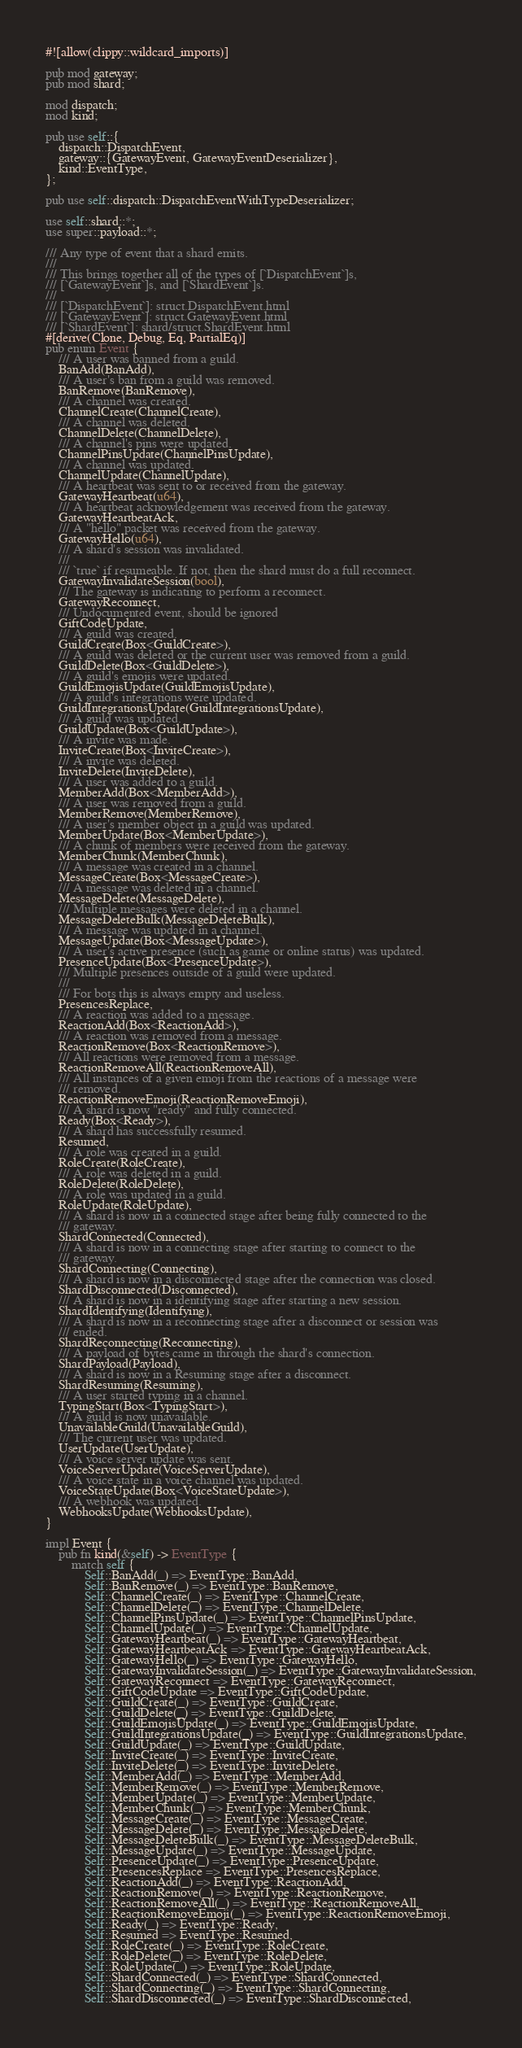<code> <loc_0><loc_0><loc_500><loc_500><_Rust_>#![allow(clippy::wildcard_imports)]

pub mod gateway;
pub mod shard;

mod dispatch;
mod kind;

pub use self::{
    dispatch::DispatchEvent,
    gateway::{GatewayEvent, GatewayEventDeserializer},
    kind::EventType,
};

pub use self::dispatch::DispatchEventWithTypeDeserializer;

use self::shard::*;
use super::payload::*;

/// Any type of event that a shard emits.
///
/// This brings together all of the types of [`DispatchEvent`]s,
/// [`GatewayEvent`]s, and [`ShardEvent`]s.
///
/// [`DispatchEvent`]: struct.DispatchEvent.html
/// [`GatewayEvent`]: struct.GatewayEvent.html
/// [`ShardEvent`]: shard/struct.ShardEvent.html
#[derive(Clone, Debug, Eq, PartialEq)]
pub enum Event {
    /// A user was banned from a guild.
    BanAdd(BanAdd),
    /// A user's ban from a guild was removed.
    BanRemove(BanRemove),
    /// A channel was created.
    ChannelCreate(ChannelCreate),
    /// A channel was deleted.
    ChannelDelete(ChannelDelete),
    /// A channel's pins were updated.
    ChannelPinsUpdate(ChannelPinsUpdate),
    /// A channel was updated.
    ChannelUpdate(ChannelUpdate),
    /// A heartbeat was sent to or received from the gateway.
    GatewayHeartbeat(u64),
    /// A heartbeat acknowledgement was received from the gateway.
    GatewayHeartbeatAck,
    /// A "hello" packet was received from the gateway.
    GatewayHello(u64),
    /// A shard's session was invalidated.
    ///
    /// `true` if resumeable. If not, then the shard must do a full reconnect.
    GatewayInvalidateSession(bool),
    /// The gateway is indicating to perform a reconnect.
    GatewayReconnect,
    /// Undocumented event, should be ignored
    GiftCodeUpdate,
    /// A guild was created.
    GuildCreate(Box<GuildCreate>),
    /// A guild was deleted or the current user was removed from a guild.
    GuildDelete(Box<GuildDelete>),
    /// A guild's emojis were updated.
    GuildEmojisUpdate(GuildEmojisUpdate),
    /// A guild's integrations were updated.
    GuildIntegrationsUpdate(GuildIntegrationsUpdate),
    /// A guild was updated.
    GuildUpdate(Box<GuildUpdate>),
    /// A invite was made.
    InviteCreate(Box<InviteCreate>),
    /// A invite was deleted.
    InviteDelete(InviteDelete),
    /// A user was added to a guild.
    MemberAdd(Box<MemberAdd>),
    /// A user was removed from a guild.
    MemberRemove(MemberRemove),
    /// A user's member object in a guild was updated.
    MemberUpdate(Box<MemberUpdate>),
    /// A chunk of members were received from the gateway.
    MemberChunk(MemberChunk),
    /// A message was created in a channel.
    MessageCreate(Box<MessageCreate>),
    /// A message was deleted in a channel.
    MessageDelete(MessageDelete),
    /// Multiple messages were deleted in a channel.
    MessageDeleteBulk(MessageDeleteBulk),
    /// A message was updated in a channel.
    MessageUpdate(Box<MessageUpdate>),
    /// A user's active presence (such as game or online status) was updated.
    PresenceUpdate(Box<PresenceUpdate>),
    /// Multiple presences outside of a guild were updated.
    ///
    /// For bots this is always empty and useless.
    PresencesReplace,
    /// A reaction was added to a message.
    ReactionAdd(Box<ReactionAdd>),
    /// A reaction was removed from a message.
    ReactionRemove(Box<ReactionRemove>),
    /// All reactions were removed from a message.
    ReactionRemoveAll(ReactionRemoveAll),
    /// All instances of a given emoji from the reactions of a message were
    /// removed.
    ReactionRemoveEmoji(ReactionRemoveEmoji),
    /// A shard is now "ready" and fully connected.
    Ready(Box<Ready>),
    /// A shard has successfully resumed.
    Resumed,
    /// A role was created in a guild.
    RoleCreate(RoleCreate),
    /// A role was deleted in a guild.
    RoleDelete(RoleDelete),
    /// A role was updated in a guild.
    RoleUpdate(RoleUpdate),
    /// A shard is now in a connected stage after being fully connected to the
    /// gateway.
    ShardConnected(Connected),
    /// A shard is now in a connecting stage after starting to connect to the
    /// gateway.
    ShardConnecting(Connecting),
    /// A shard is now in a disconnected stage after the connection was closed.
    ShardDisconnected(Disconnected),
    /// A shard is now in a identifying stage after starting a new session.
    ShardIdentifying(Identifying),
    /// A shard is now in a reconnecting stage after a disconnect or session was
    /// ended.
    ShardReconnecting(Reconnecting),
    /// A payload of bytes came in through the shard's connection.
    ShardPayload(Payload),
    /// A shard is now in a Resuming stage after a disconnect.
    ShardResuming(Resuming),
    /// A user started typing in a channel.
    TypingStart(Box<TypingStart>),
    /// A guild is now unavailable.
    UnavailableGuild(UnavailableGuild),
    /// The current user was updated.
    UserUpdate(UserUpdate),
    /// A voice server update was sent.
    VoiceServerUpdate(VoiceServerUpdate),
    /// A voice state in a voice channel was updated.
    VoiceStateUpdate(Box<VoiceStateUpdate>),
    /// A webhook was updated.
    WebhooksUpdate(WebhooksUpdate),
}

impl Event {
    pub fn kind(&self) -> EventType {
        match self {
            Self::BanAdd(_) => EventType::BanAdd,
            Self::BanRemove(_) => EventType::BanRemove,
            Self::ChannelCreate(_) => EventType::ChannelCreate,
            Self::ChannelDelete(_) => EventType::ChannelDelete,
            Self::ChannelPinsUpdate(_) => EventType::ChannelPinsUpdate,
            Self::ChannelUpdate(_) => EventType::ChannelUpdate,
            Self::GatewayHeartbeat(_) => EventType::GatewayHeartbeat,
            Self::GatewayHeartbeatAck => EventType::GatewayHeartbeatAck,
            Self::GatewayHello(_) => EventType::GatewayHello,
            Self::GatewayInvalidateSession(_) => EventType::GatewayInvalidateSession,
            Self::GatewayReconnect => EventType::GatewayReconnect,
            Self::GiftCodeUpdate => EventType::GiftCodeUpdate,
            Self::GuildCreate(_) => EventType::GuildCreate,
            Self::GuildDelete(_) => EventType::GuildDelete,
            Self::GuildEmojisUpdate(_) => EventType::GuildEmojisUpdate,
            Self::GuildIntegrationsUpdate(_) => EventType::GuildIntegrationsUpdate,
            Self::GuildUpdate(_) => EventType::GuildUpdate,
            Self::InviteCreate(_) => EventType::InviteCreate,
            Self::InviteDelete(_) => EventType::InviteDelete,
            Self::MemberAdd(_) => EventType::MemberAdd,
            Self::MemberRemove(_) => EventType::MemberRemove,
            Self::MemberUpdate(_) => EventType::MemberUpdate,
            Self::MemberChunk(_) => EventType::MemberChunk,
            Self::MessageCreate(_) => EventType::MessageCreate,
            Self::MessageDelete(_) => EventType::MessageDelete,
            Self::MessageDeleteBulk(_) => EventType::MessageDeleteBulk,
            Self::MessageUpdate(_) => EventType::MessageUpdate,
            Self::PresenceUpdate(_) => EventType::PresenceUpdate,
            Self::PresencesReplace => EventType::PresencesReplace,
            Self::ReactionAdd(_) => EventType::ReactionAdd,
            Self::ReactionRemove(_) => EventType::ReactionRemove,
            Self::ReactionRemoveAll(_) => EventType::ReactionRemoveAll,
            Self::ReactionRemoveEmoji(_) => EventType::ReactionRemoveEmoji,
            Self::Ready(_) => EventType::Ready,
            Self::Resumed => EventType::Resumed,
            Self::RoleCreate(_) => EventType::RoleCreate,
            Self::RoleDelete(_) => EventType::RoleDelete,
            Self::RoleUpdate(_) => EventType::RoleUpdate,
            Self::ShardConnected(_) => EventType::ShardConnected,
            Self::ShardConnecting(_) => EventType::ShardConnecting,
            Self::ShardDisconnected(_) => EventType::ShardDisconnected,</code> 